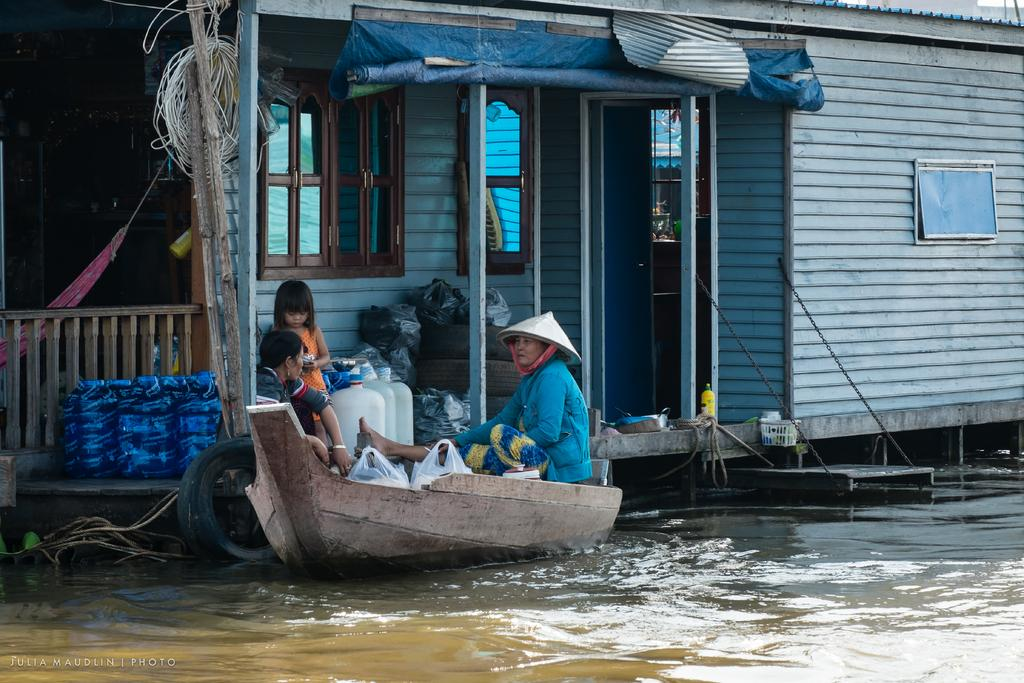How many women are in the image? There are two women in the image. What are the women doing in the image? The women are sitting in a small boat. What is the setting of the image? There is water visible in the image, and it appears to be a small canal. What can be seen in the background of the image? There is a shed house in the background of the image. What are the features of the shed house? The shed house has glass windows and doors. How many chickens are sitting on the calendar in the image? There are no chickens or calendars present in the image. Is there a quilt covering the women in the boat? There is no quilt visible in the image; the women are sitting in a small boat without any covering. 